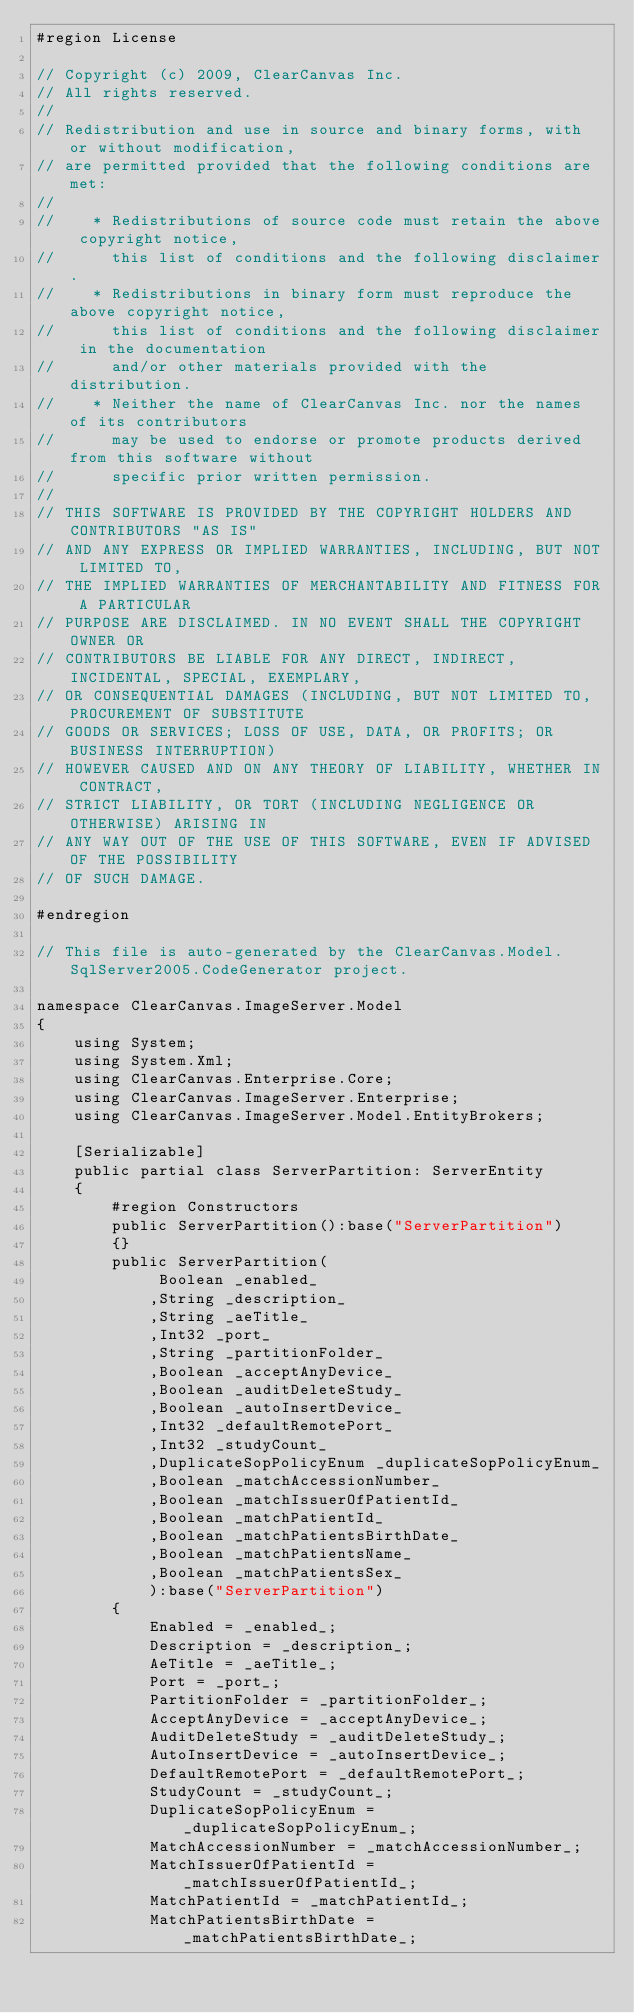Convert code to text. <code><loc_0><loc_0><loc_500><loc_500><_C#_>#region License

// Copyright (c) 2009, ClearCanvas Inc.
// All rights reserved.
//
// Redistribution and use in source and binary forms, with or without modification, 
// are permitted provided that the following conditions are met:
//
//    * Redistributions of source code must retain the above copyright notice, 
//      this list of conditions and the following disclaimer.
//    * Redistributions in binary form must reproduce the above copyright notice, 
//      this list of conditions and the following disclaimer in the documentation 
//      and/or other materials provided with the distribution.
//    * Neither the name of ClearCanvas Inc. nor the names of its contributors 
//      may be used to endorse or promote products derived from this software without 
//      specific prior written permission.
//
// THIS SOFTWARE IS PROVIDED BY THE COPYRIGHT HOLDERS AND CONTRIBUTORS "AS IS" 
// AND ANY EXPRESS OR IMPLIED WARRANTIES, INCLUDING, BUT NOT LIMITED TO, 
// THE IMPLIED WARRANTIES OF MERCHANTABILITY AND FITNESS FOR A PARTICULAR 
// PURPOSE ARE DISCLAIMED. IN NO EVENT SHALL THE COPYRIGHT OWNER OR 
// CONTRIBUTORS BE LIABLE FOR ANY DIRECT, INDIRECT, INCIDENTAL, SPECIAL, EXEMPLARY, 
// OR CONSEQUENTIAL DAMAGES (INCLUDING, BUT NOT LIMITED TO, PROCUREMENT OF SUBSTITUTE 
// GOODS OR SERVICES; LOSS OF USE, DATA, OR PROFITS; OR BUSINESS INTERRUPTION) 
// HOWEVER CAUSED AND ON ANY THEORY OF LIABILITY, WHETHER IN CONTRACT, 
// STRICT LIABILITY, OR TORT (INCLUDING NEGLIGENCE OR OTHERWISE) ARISING IN 
// ANY WAY OUT OF THE USE OF THIS SOFTWARE, EVEN IF ADVISED OF THE POSSIBILITY 
// OF SUCH DAMAGE.

#endregion

// This file is auto-generated by the ClearCanvas.Model.SqlServer2005.CodeGenerator project.

namespace ClearCanvas.ImageServer.Model
{
    using System;
    using System.Xml;
    using ClearCanvas.Enterprise.Core;
    using ClearCanvas.ImageServer.Enterprise;
    using ClearCanvas.ImageServer.Model.EntityBrokers;

    [Serializable]
    public partial class ServerPartition: ServerEntity
    {
        #region Constructors
        public ServerPartition():base("ServerPartition")
        {}
        public ServerPartition(
             Boolean _enabled_
            ,String _description_
            ,String _aeTitle_
            ,Int32 _port_
            ,String _partitionFolder_
            ,Boolean _acceptAnyDevice_
            ,Boolean _auditDeleteStudy_
            ,Boolean _autoInsertDevice_
            ,Int32 _defaultRemotePort_
            ,Int32 _studyCount_
            ,DuplicateSopPolicyEnum _duplicateSopPolicyEnum_
            ,Boolean _matchAccessionNumber_
            ,Boolean _matchIssuerOfPatientId_
            ,Boolean _matchPatientId_
            ,Boolean _matchPatientsBirthDate_
            ,Boolean _matchPatientsName_
            ,Boolean _matchPatientsSex_
            ):base("ServerPartition")
        {
            Enabled = _enabled_;
            Description = _description_;
            AeTitle = _aeTitle_;
            Port = _port_;
            PartitionFolder = _partitionFolder_;
            AcceptAnyDevice = _acceptAnyDevice_;
            AuditDeleteStudy = _auditDeleteStudy_;
            AutoInsertDevice = _autoInsertDevice_;
            DefaultRemotePort = _defaultRemotePort_;
            StudyCount = _studyCount_;
            DuplicateSopPolicyEnum = _duplicateSopPolicyEnum_;
            MatchAccessionNumber = _matchAccessionNumber_;
            MatchIssuerOfPatientId = _matchIssuerOfPatientId_;
            MatchPatientId = _matchPatientId_;
            MatchPatientsBirthDate = _matchPatientsBirthDate_;</code> 